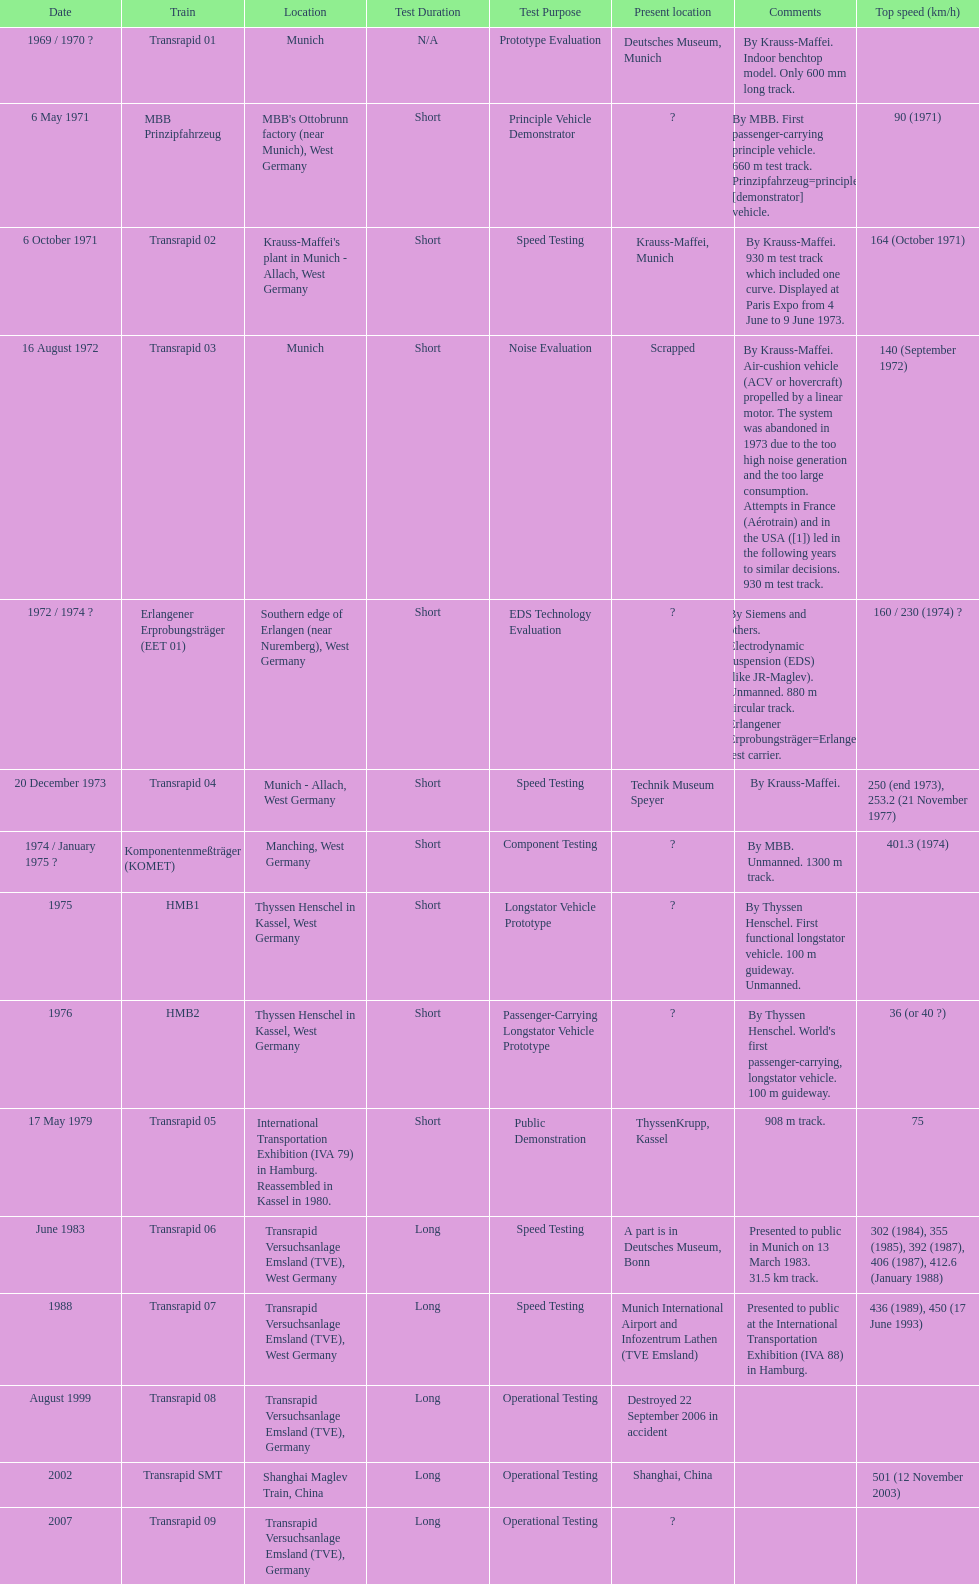How many trains other than the transrapid 07 can go faster than 450km/h? 1. 